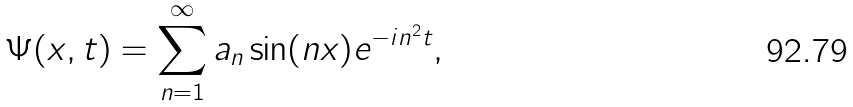Convert formula to latex. <formula><loc_0><loc_0><loc_500><loc_500>\Psi ( x , t ) = \sum _ { n = 1 } ^ { \infty } a _ { n } \sin ( n x ) e ^ { - i n ^ { 2 } t } ,</formula> 